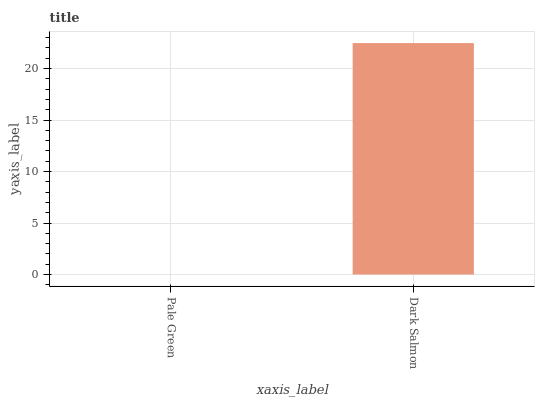Is Pale Green the minimum?
Answer yes or no. Yes. Is Dark Salmon the maximum?
Answer yes or no. Yes. Is Dark Salmon the minimum?
Answer yes or no. No. Is Dark Salmon greater than Pale Green?
Answer yes or no. Yes. Is Pale Green less than Dark Salmon?
Answer yes or no. Yes. Is Pale Green greater than Dark Salmon?
Answer yes or no. No. Is Dark Salmon less than Pale Green?
Answer yes or no. No. Is Dark Salmon the high median?
Answer yes or no. Yes. Is Pale Green the low median?
Answer yes or no. Yes. Is Pale Green the high median?
Answer yes or no. No. Is Dark Salmon the low median?
Answer yes or no. No. 